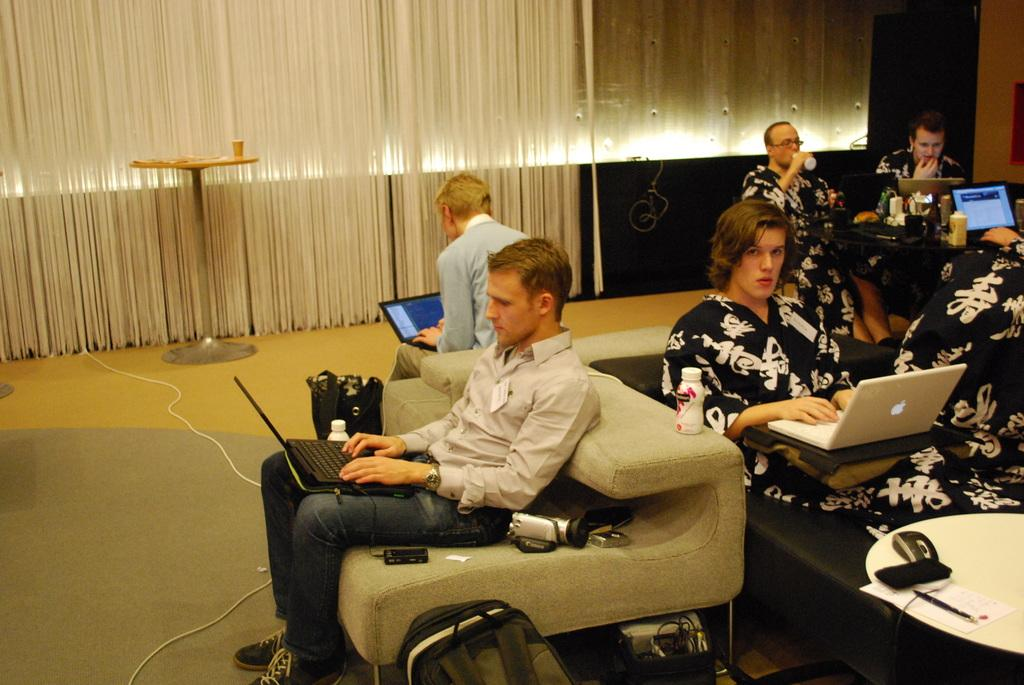What is the main activity of the people in the image? The people in the image are working on laptops. How are the people positioned in the image? The people are seated. Can you describe the man in the image? There is a man drinking in the image. What type of window treatment is visible in the image? There are blinds visible in the image. How many horses are present in the image? There are no horses present in the image. What type of cushion is being used by the people in the image? There is no mention of cushions in the image; the people are seated on chairs or other furniture. 